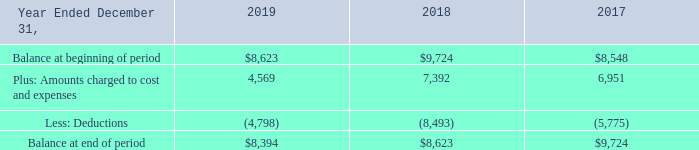Liability for Warranty
Liability for Warranty Our products generally include warranties of 90 days to five years for product defects. We accrue for warranty returns at the time revenue is recognized based on our historical return rate and estimate of the cost to repair or replace the defective products. We engage in extensive product quality programs and processes, including actively monitoring and evaluating the quality of our component suppliers. The increasing complexity of our products will cause warranty incidences, when they arise, to be more costly. Our estimates regarding future warranty obligations may change due to product failure rates, material usage and other rework costs incurred in correcting a product failure. In addition, from time to time, specific warranty accruals may be recorded if unforeseen problems arise. Should our actual experience relative to these factors be worse than our estimates, we will be required to record additional warranty expense. Alternatively, if we provide for more reserves than we require, we will reverse a portion of such provisions in future periods. The liability for warranty obligations totaled $8.4 million and $8.6 million as of December 31, 2019 and 2018, respectively. These liabilities are included in accrued expenses in the accompanying Consolidated Balance Sheets. During 2017, we recorded a reduction in warranty expense related to a settlement with a third-party supplier for a defective component, the impact of which is reflected in the following table.
A summary of warranty expense and write-off activity for the years ended December 31, 2019, 2018 and 2017 is as follows:
(In thousands)
What was the liability for warranty obligations in 2019? $8.4 million. What was the balance at beginning of period in 2019?
Answer scale should be: thousand. $8,623. What was the  Balance at end of period in 2017?
Answer scale should be: thousand. $9,724. What was the change in the balance at the beginning of period between 2018 and 2019?
Answer scale should be: thousand. $8,623-$9,724
Answer: -1101. What was the change in the balance at the end of period between 2018 and 2019?
Answer scale should be: thousand. $8,394-$8,623
Answer: -229. What was the percentage change in amounts charged to cost and expenses between 2017 and 2018?
Answer scale should be: percent. (7,392-6,951)/6,951
Answer: 6.34. 